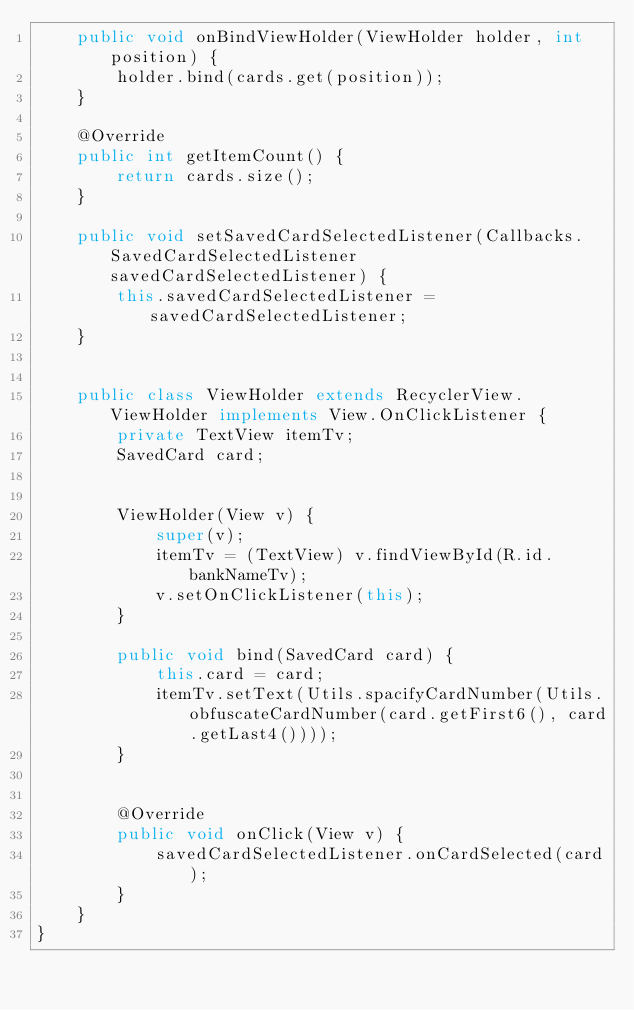<code> <loc_0><loc_0><loc_500><loc_500><_Java_>    public void onBindViewHolder(ViewHolder holder, int position) {
        holder.bind(cards.get(position));
    }

    @Override
    public int getItemCount() {
        return cards.size();
    }

    public void setSavedCardSelectedListener(Callbacks.SavedCardSelectedListener savedCardSelectedListener) {
        this.savedCardSelectedListener = savedCardSelectedListener;
    }


    public class ViewHolder extends RecyclerView.ViewHolder implements View.OnClickListener {
        private TextView itemTv;
        SavedCard card;


        ViewHolder(View v) {
            super(v);
            itemTv = (TextView) v.findViewById(R.id.bankNameTv);
            v.setOnClickListener(this);
        }

        public void bind(SavedCard card) {
            this.card = card;
            itemTv.setText(Utils.spacifyCardNumber(Utils.obfuscateCardNumber(card.getFirst6(), card.getLast4())));
        }


        @Override
        public void onClick(View v) {
            savedCardSelectedListener.onCardSelected(card);
        }
    }
}
</code> 